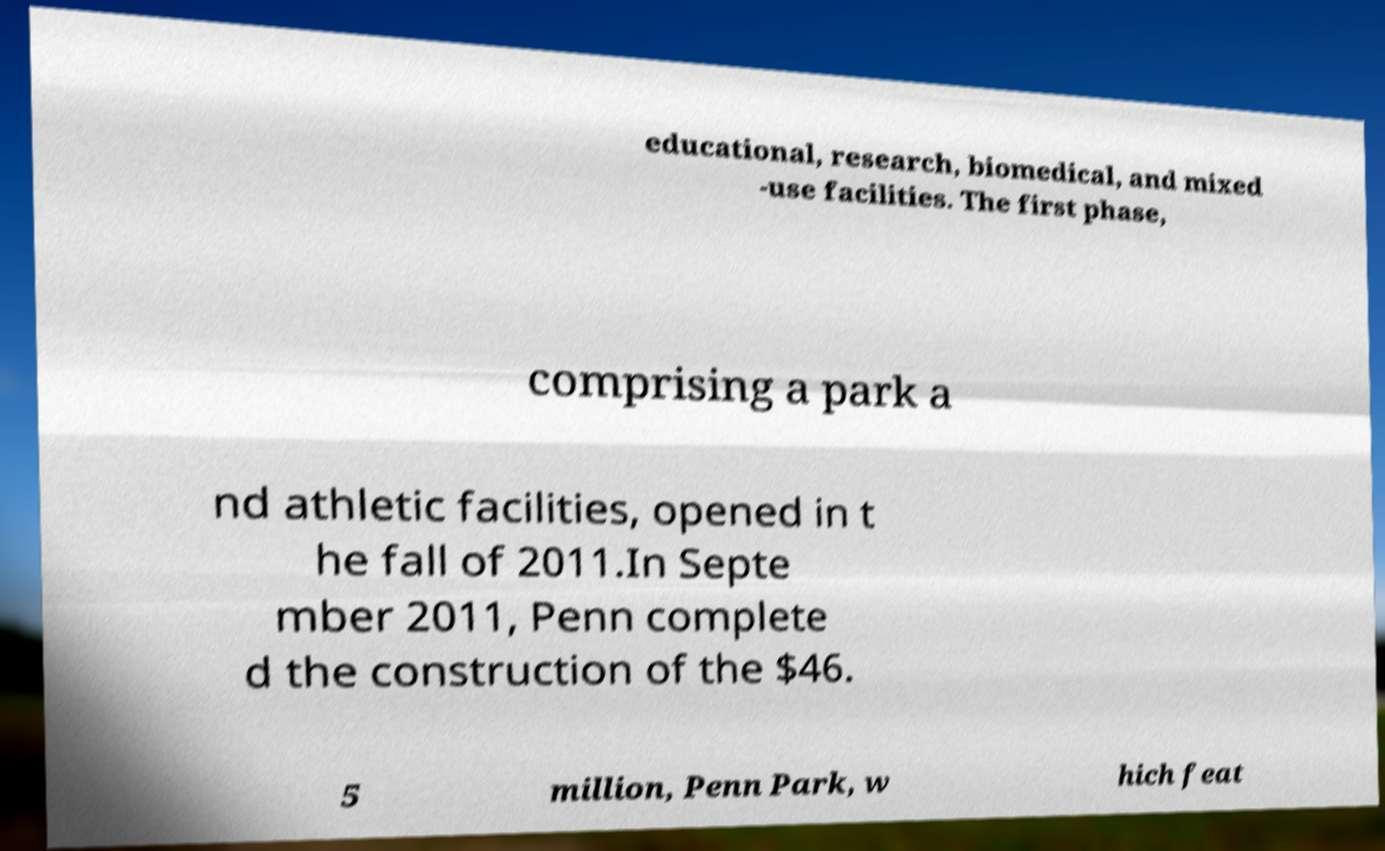There's text embedded in this image that I need extracted. Can you transcribe it verbatim? educational, research, biomedical, and mixed -use facilities. The first phase, comprising a park a nd athletic facilities, opened in t he fall of 2011.In Septe mber 2011, Penn complete d the construction of the $46. 5 million, Penn Park, w hich feat 